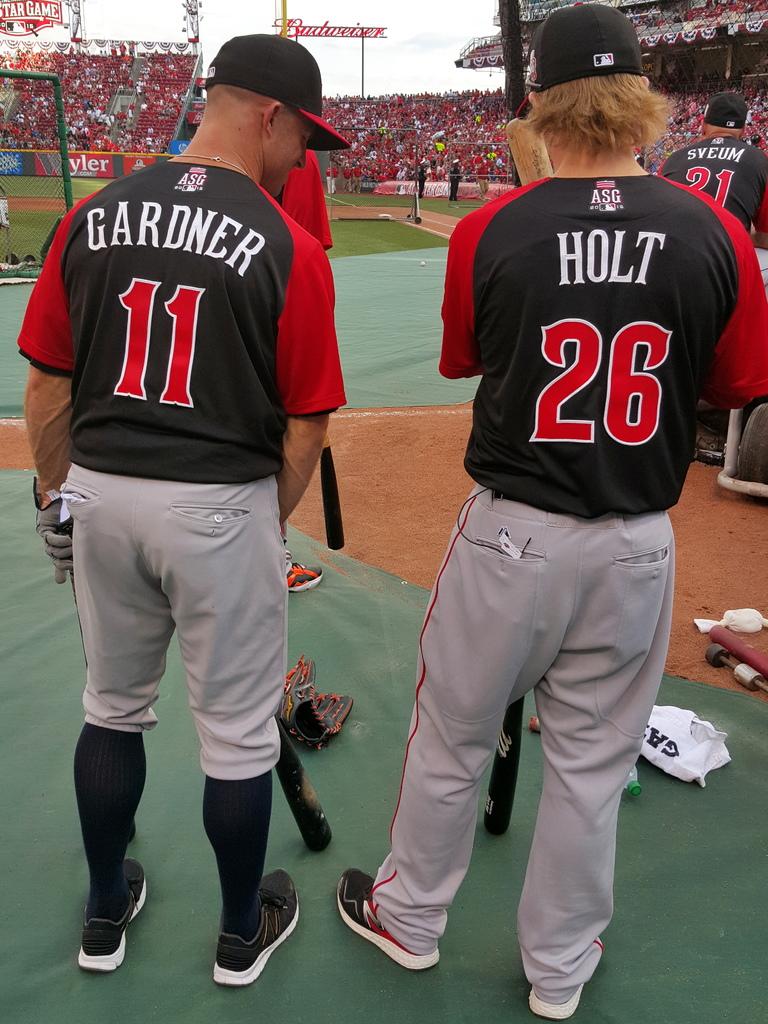What is the name on the player on the right?
Your answer should be very brief. Holt. 